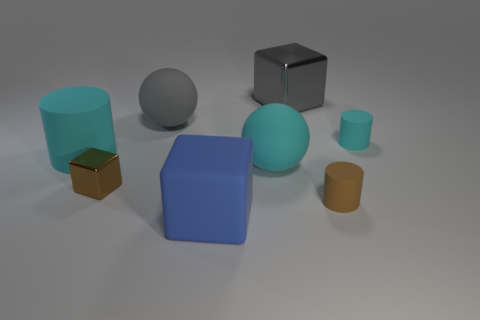What is the size of the block that is made of the same material as the large gray ball?
Your response must be concise. Large. What material is the tiny object that is both behind the brown rubber thing and right of the large gray metal thing?
Your answer should be very brief. Rubber. What number of green rubber things are the same size as the blue matte block?
Make the answer very short. 0. There is a large gray thing that is the same shape as the blue matte object; what is its material?
Keep it short and to the point. Metal. What number of objects are cyan balls that are in front of the large gray ball or large cyan matte things that are right of the big gray ball?
Ensure brevity in your answer.  1. There is a gray metal object; does it have the same shape as the gray thing that is in front of the big gray metallic object?
Ensure brevity in your answer.  No. There is a small matte object in front of the cyan object right of the tiny cylinder in front of the large cyan ball; what shape is it?
Offer a terse response. Cylinder. What number of other objects are the same material as the big cyan sphere?
Give a very brief answer. 5. How many things are either matte cylinders to the left of the gray rubber sphere or shiny objects?
Make the answer very short. 3. There is a rubber thing in front of the brown object right of the gray metallic thing; what is its shape?
Offer a very short reply. Cube. 